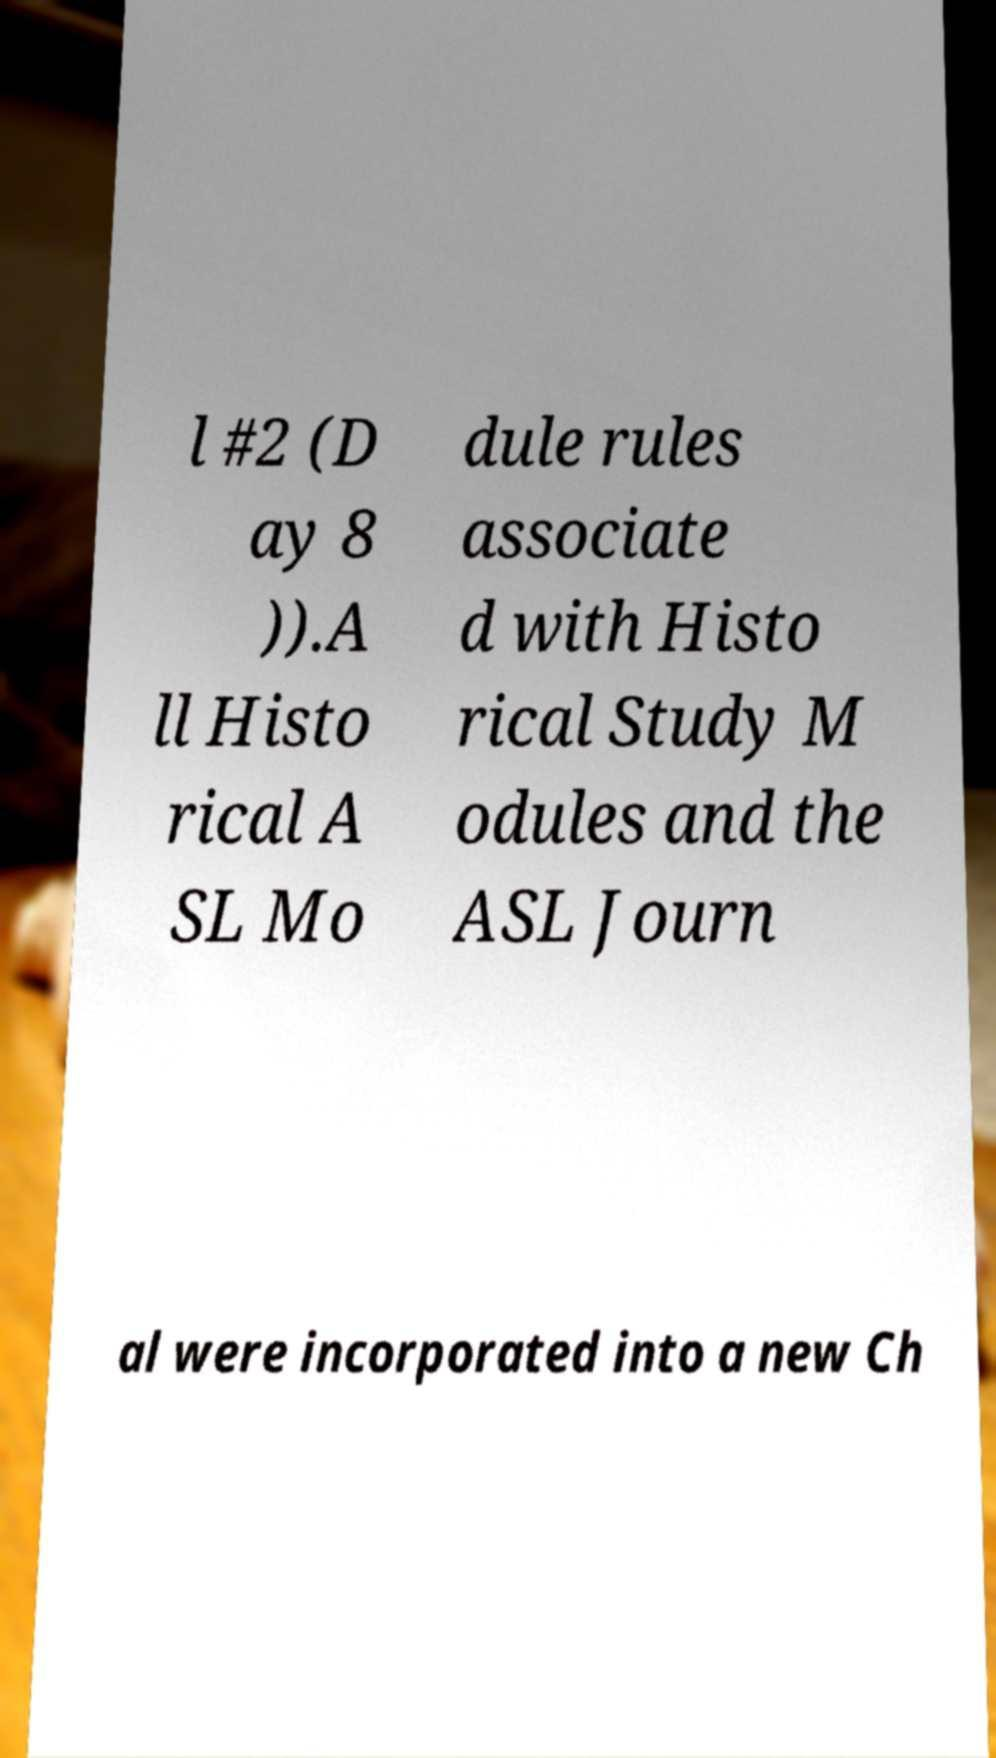I need the written content from this picture converted into text. Can you do that? l #2 (D ay 8 )).A ll Histo rical A SL Mo dule rules associate d with Histo rical Study M odules and the ASL Journ al were incorporated into a new Ch 